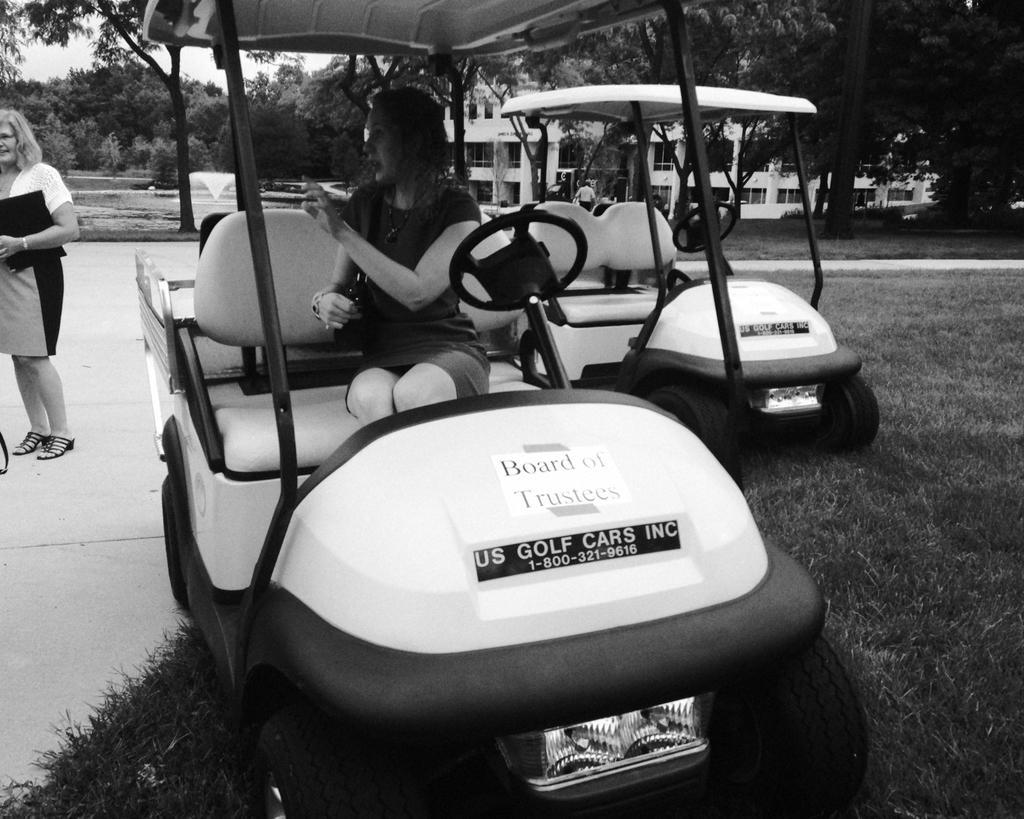In one or two sentences, can you explain what this image depicts? In this image I can see a person sitting in the vehicle. Background I can see the person standing, few vehicles, trees and sky, and the image is in black and white. 